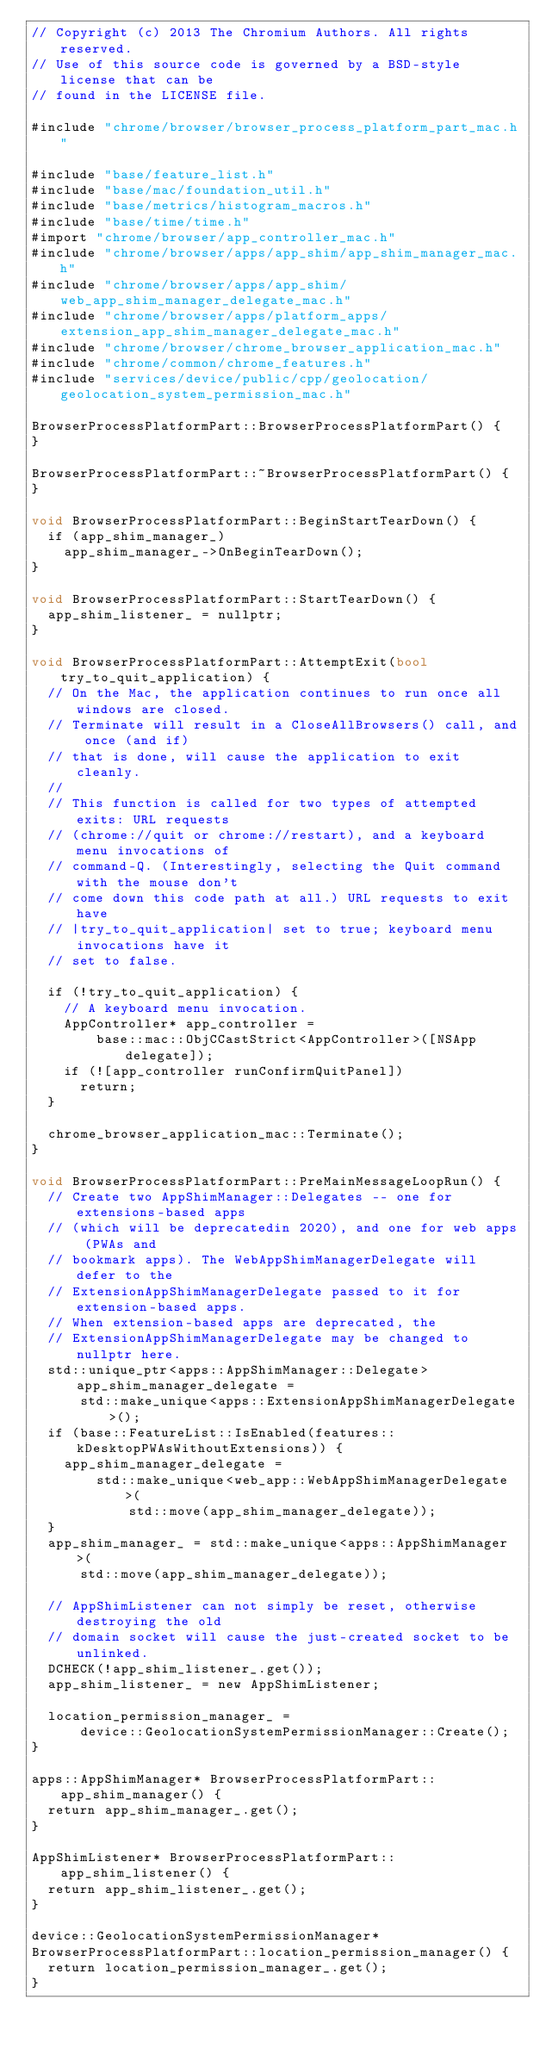Convert code to text. <code><loc_0><loc_0><loc_500><loc_500><_ObjectiveC_>// Copyright (c) 2013 The Chromium Authors. All rights reserved.
// Use of this source code is governed by a BSD-style license that can be
// found in the LICENSE file.

#include "chrome/browser/browser_process_platform_part_mac.h"

#include "base/feature_list.h"
#include "base/mac/foundation_util.h"
#include "base/metrics/histogram_macros.h"
#include "base/time/time.h"
#import "chrome/browser/app_controller_mac.h"
#include "chrome/browser/apps/app_shim/app_shim_manager_mac.h"
#include "chrome/browser/apps/app_shim/web_app_shim_manager_delegate_mac.h"
#include "chrome/browser/apps/platform_apps/extension_app_shim_manager_delegate_mac.h"
#include "chrome/browser/chrome_browser_application_mac.h"
#include "chrome/common/chrome_features.h"
#include "services/device/public/cpp/geolocation/geolocation_system_permission_mac.h"

BrowserProcessPlatformPart::BrowserProcessPlatformPart() {
}

BrowserProcessPlatformPart::~BrowserProcessPlatformPart() {
}

void BrowserProcessPlatformPart::BeginStartTearDown() {
  if (app_shim_manager_)
    app_shim_manager_->OnBeginTearDown();
}

void BrowserProcessPlatformPart::StartTearDown() {
  app_shim_listener_ = nullptr;
}

void BrowserProcessPlatformPart::AttemptExit(bool try_to_quit_application) {
  // On the Mac, the application continues to run once all windows are closed.
  // Terminate will result in a CloseAllBrowsers() call, and once (and if)
  // that is done, will cause the application to exit cleanly.
  //
  // This function is called for two types of attempted exits: URL requests
  // (chrome://quit or chrome://restart), and a keyboard menu invocations of
  // command-Q. (Interestingly, selecting the Quit command with the mouse don't
  // come down this code path at all.) URL requests to exit have
  // |try_to_quit_application| set to true; keyboard menu invocations have it
  // set to false.

  if (!try_to_quit_application) {
    // A keyboard menu invocation.
    AppController* app_controller =
        base::mac::ObjCCastStrict<AppController>([NSApp delegate]);
    if (![app_controller runConfirmQuitPanel])
      return;
  }

  chrome_browser_application_mac::Terminate();
}

void BrowserProcessPlatformPart::PreMainMessageLoopRun() {
  // Create two AppShimManager::Delegates -- one for extensions-based apps
  // (which will be deprecatedin 2020), and one for web apps (PWAs and
  // bookmark apps). The WebAppShimManagerDelegate will defer to the
  // ExtensionAppShimManagerDelegate passed to it for extension-based apps.
  // When extension-based apps are deprecated, the
  // ExtensionAppShimManagerDelegate may be changed to nullptr here.
  std::unique_ptr<apps::AppShimManager::Delegate> app_shim_manager_delegate =
      std::make_unique<apps::ExtensionAppShimManagerDelegate>();
  if (base::FeatureList::IsEnabled(features::kDesktopPWAsWithoutExtensions)) {
    app_shim_manager_delegate =
        std::make_unique<web_app::WebAppShimManagerDelegate>(
            std::move(app_shim_manager_delegate));
  }
  app_shim_manager_ = std::make_unique<apps::AppShimManager>(
      std::move(app_shim_manager_delegate));

  // AppShimListener can not simply be reset, otherwise destroying the old
  // domain socket will cause the just-created socket to be unlinked.
  DCHECK(!app_shim_listener_.get());
  app_shim_listener_ = new AppShimListener;

  location_permission_manager_ =
      device::GeolocationSystemPermissionManager::Create();
}

apps::AppShimManager* BrowserProcessPlatformPart::app_shim_manager() {
  return app_shim_manager_.get();
}

AppShimListener* BrowserProcessPlatformPart::app_shim_listener() {
  return app_shim_listener_.get();
}

device::GeolocationSystemPermissionManager*
BrowserProcessPlatformPart::location_permission_manager() {
  return location_permission_manager_.get();
}</code> 